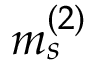<formula> <loc_0><loc_0><loc_500><loc_500>m _ { s } ^ { ( 2 ) }</formula> 